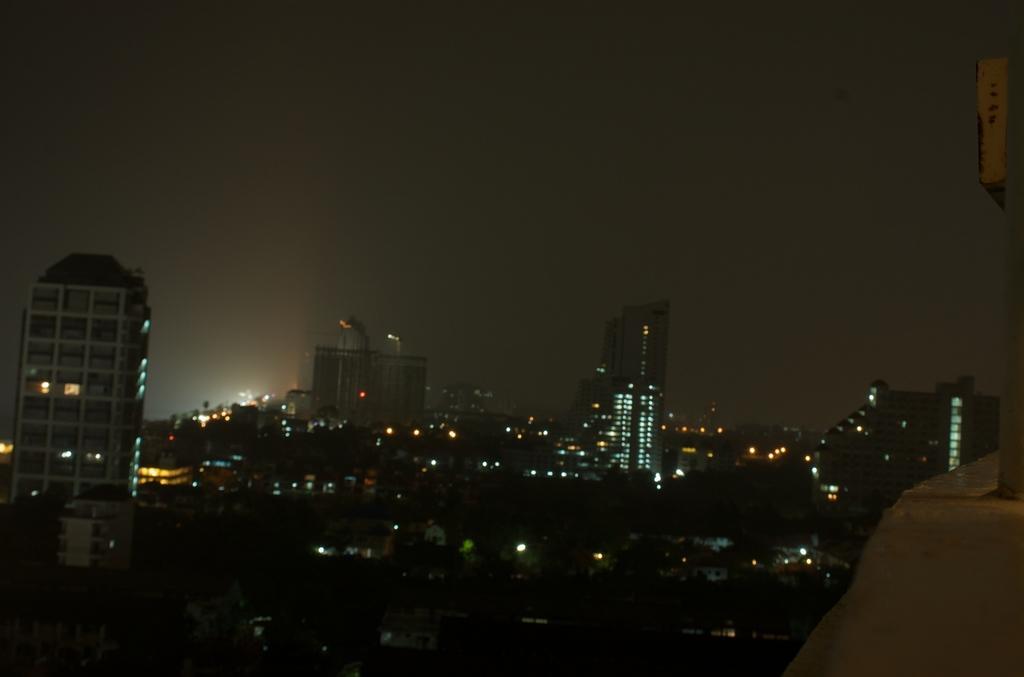In one or two sentences, can you explain what this image depicts? This picture is taken in the dark. This is an image of a city in the dark. I can see buildings with some lights all over the city. At the top of the image I can see the sky.  